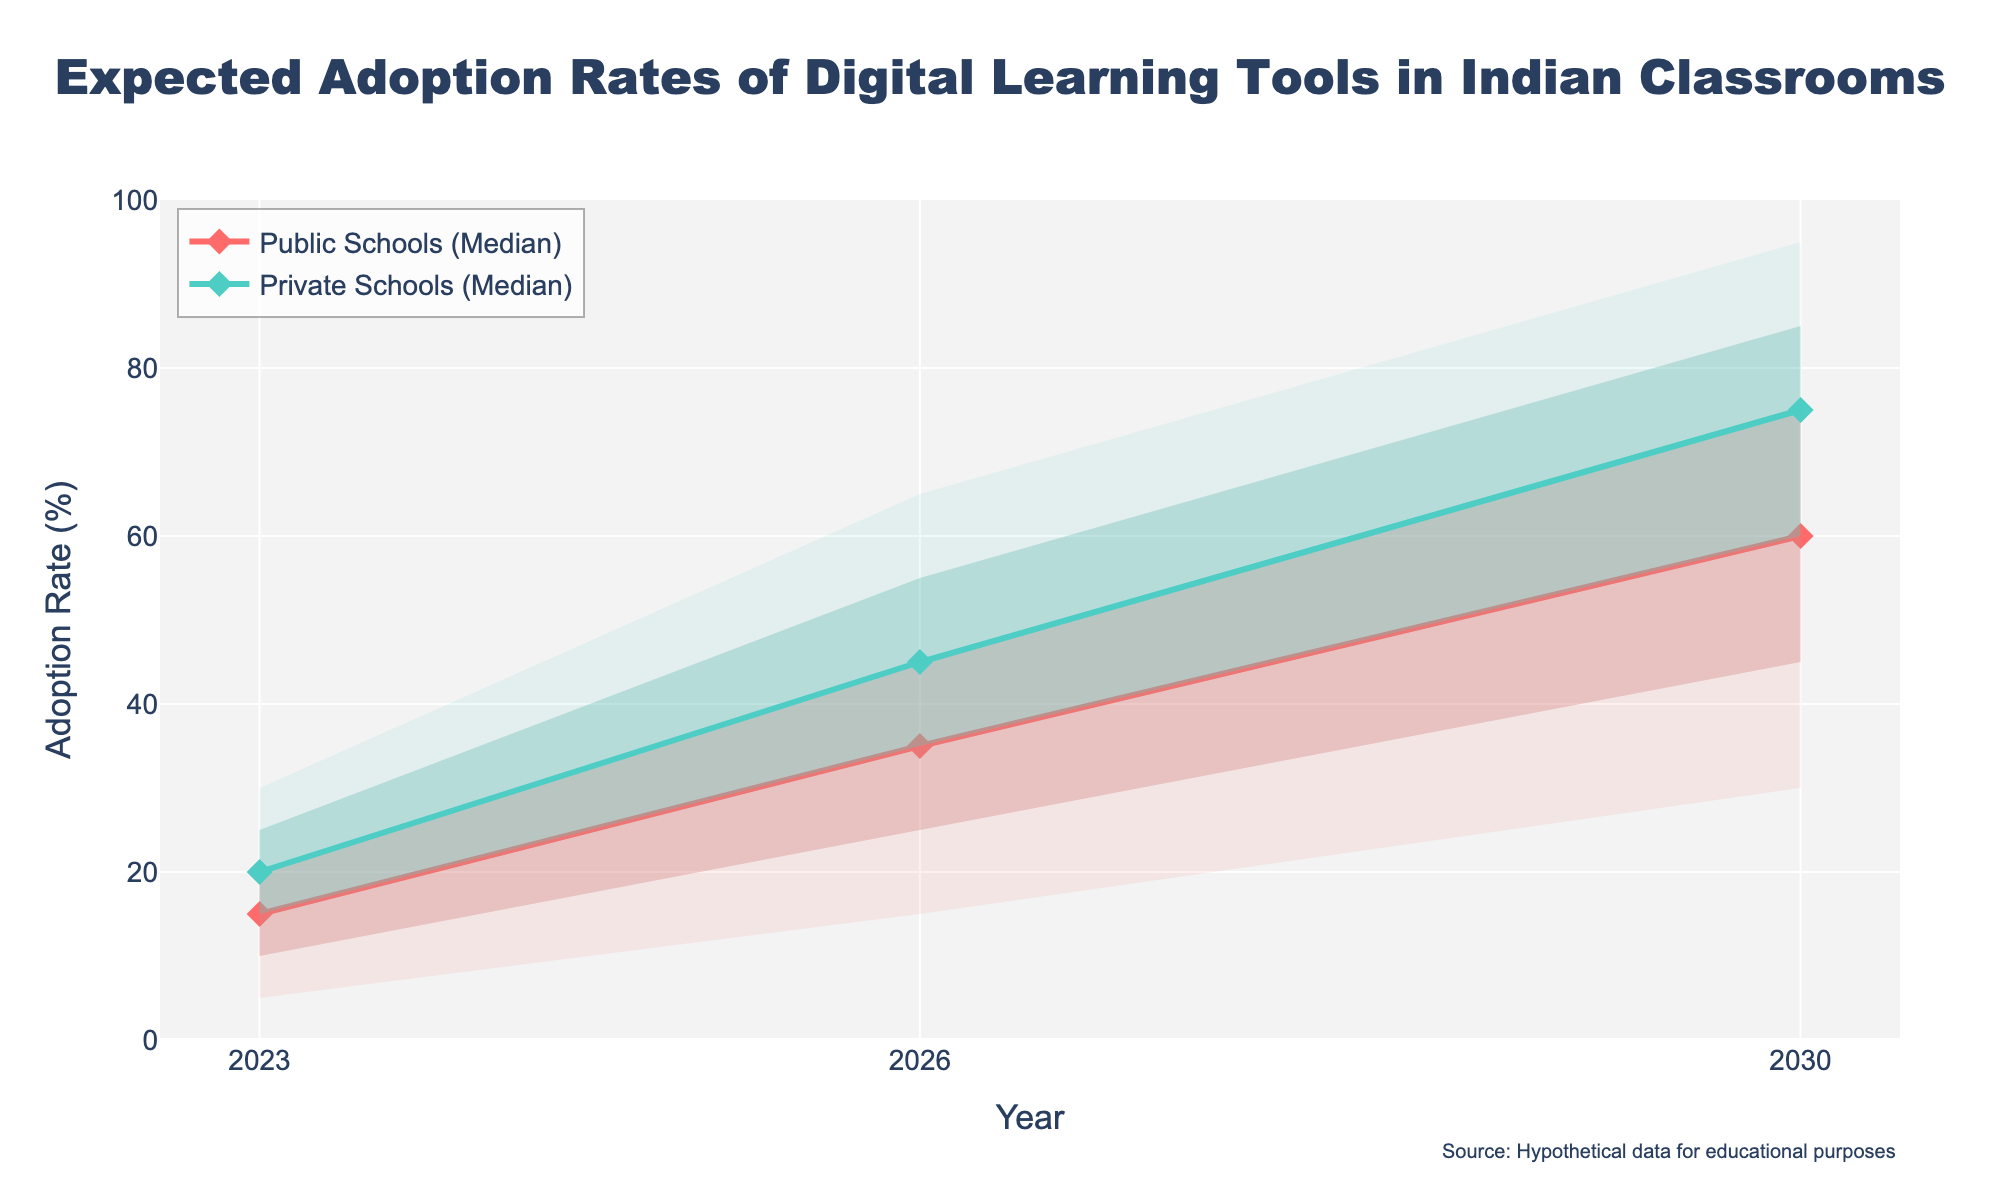what is the title of the figure? The title is located at the top center of the figure. It describes the content of the chart.
Answer: Expected Adoption Rates of Digital Learning Tools in Indian Classrooms How many adoption rates percentiles are depicted for each school type? The figure shows five different percentiles for each school type: 10th, 25th, 50th (Median), 75th, and 90th percentiles.
Answer: Five Which school type is expected to have a higher median adoption rate in 2026? Compare the median line (dots connected by lines) for both school types in the year 2026. The orange line represents Public Schools, and the turquoise line represents Private Schools. The turquoise line is higher.
Answer: Private Schools What is the expected range of adoption rates for public schools in 2030 between the 10th and 90th percentiles? Look at the shaded area for Public Schools in 2030 between the 10th and 90th percentiles. It's bounded by the edges of the light orange area.
Answer: 30% to 85% By how much is the median adoption rate for private schools expected to increase from 2023 to 2030? Note the median values for Private Schools in 2023 and 2030, which are 20% and 75%, respectively. Subtract the 2023 value from the 2030 value.
Answer: 55% What is the expected median adoption rate for public schools in 2026? Locate the median line (the main line connecting diamond markers) for Public Schools in 2026. It's at 35%.
Answer: 35% In which year is the interquartile range (IQR) for private schools' adoption rates the widest? The interquartile range is the range between the 25th and 75th percentiles. Compare the width of the turquoise shaded areas for Private Schools across the years 2023, 2026, and 2030.
Answer: 2026 How does the predicted adoption rate for public schools overall compare to that of private schools over the given years? Observe both the median lines and shading areas; Private Schools consistently show higher adoption rates and wider uncertainty bounds compared to Public Schools.
Answer: Private schools have higher adoption rates What is the 75th percentile adoption rate for public schools in 2023? Look at the point where the Public Schools' shading ends at the higher bound for 2023. It's at 20%.
Answer: 20% 